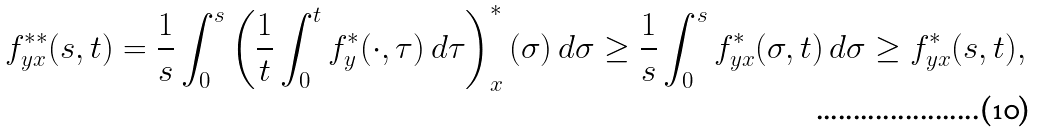Convert formula to latex. <formula><loc_0><loc_0><loc_500><loc_500>f _ { y x } ^ { \ast \ast } ( s , t ) = \frac { 1 } { s } \int _ { 0 } ^ { s } \left ( \frac { 1 } { t } \int _ { 0 } ^ { t } f _ { y } ^ { \ast } ( \cdot , \tau ) \, d \tau \right ) _ { x } ^ { \ast } ( \sigma ) \, d \sigma \geq \frac { 1 } { s } \int _ { 0 } ^ { s } f _ { y x } ^ { \ast } ( \sigma , t ) \, d \sigma \geq f _ { y x } ^ { \ast } ( s , t ) ,</formula> 